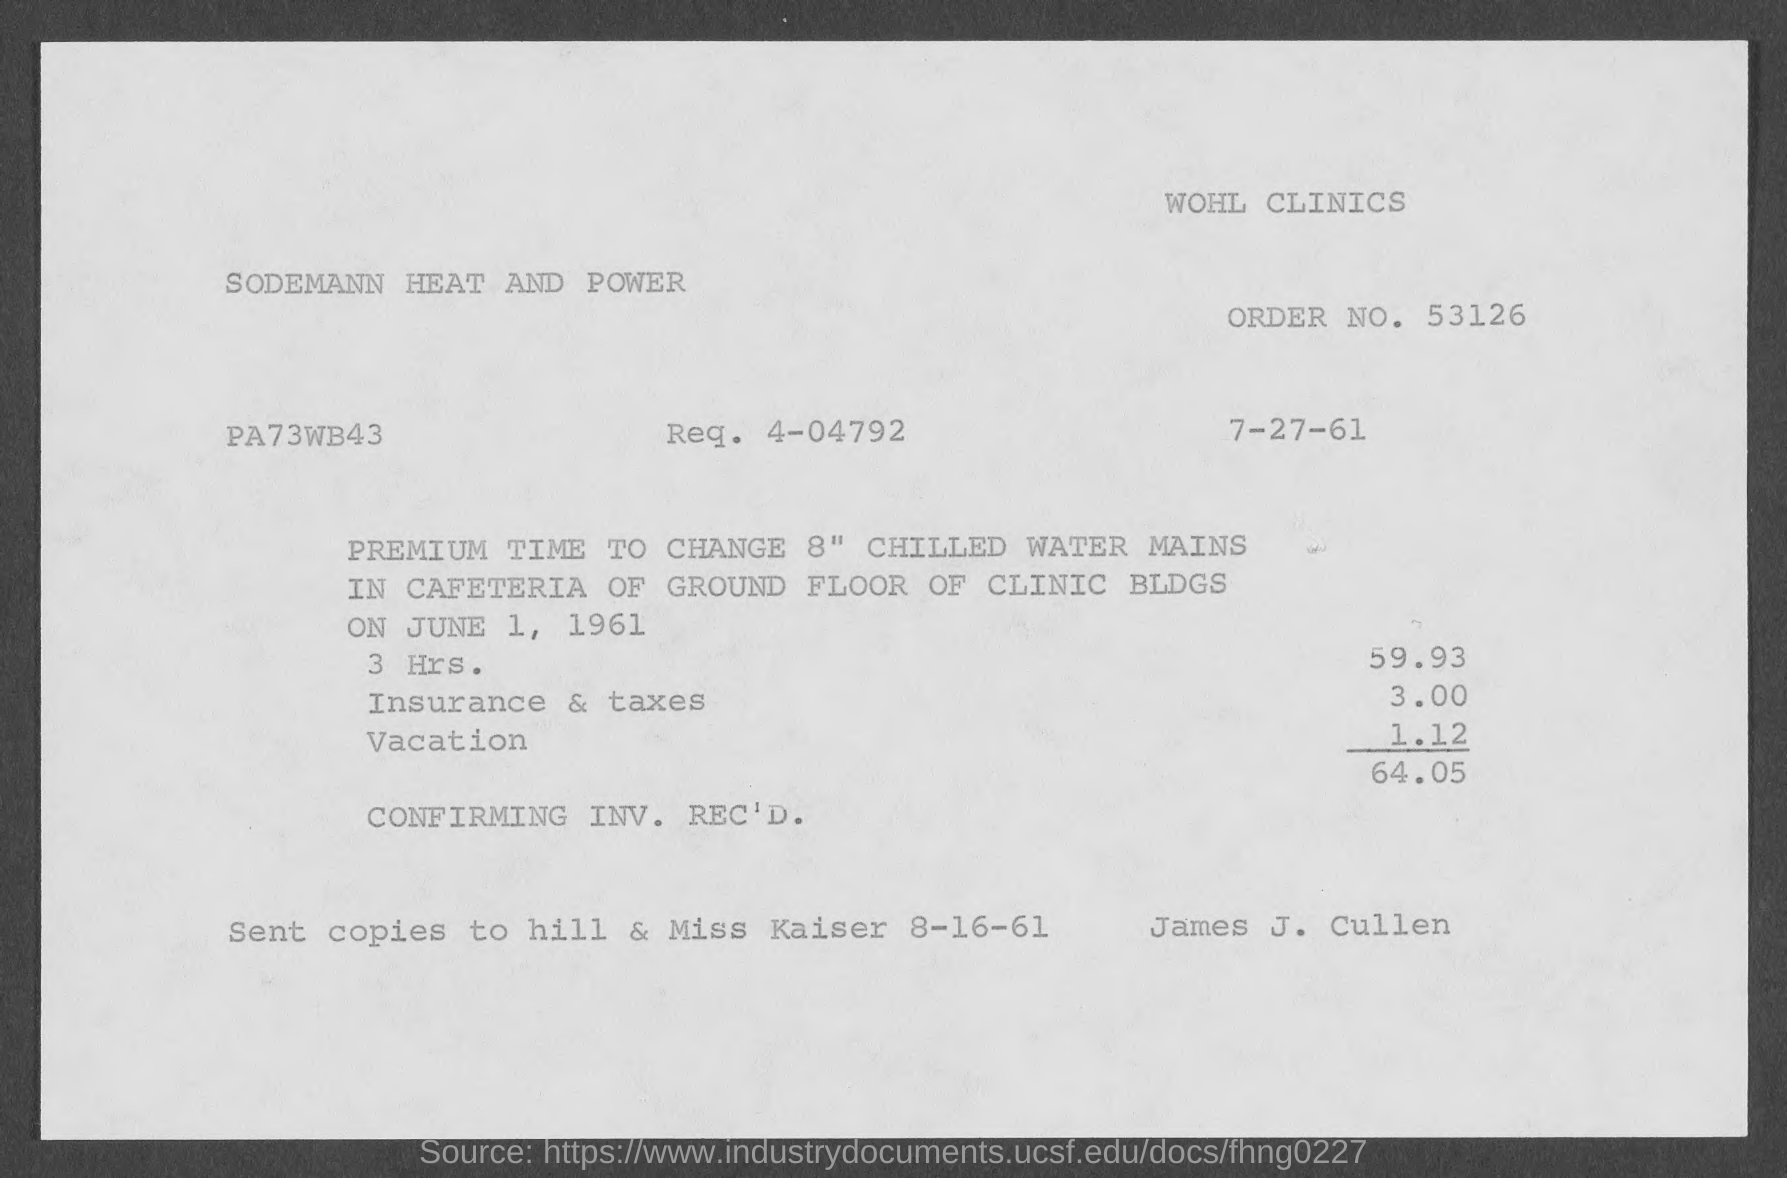What is the Order No. given in the invoice?
Offer a very short reply. 53126. What is the issued date of the invoice?
Your response must be concise. 7-27-61. What is the Req. No. given in the invoice?
Your response must be concise. 4-04792. What is the total invoice amount as per the document?
Your answer should be very brief. 64.05. 